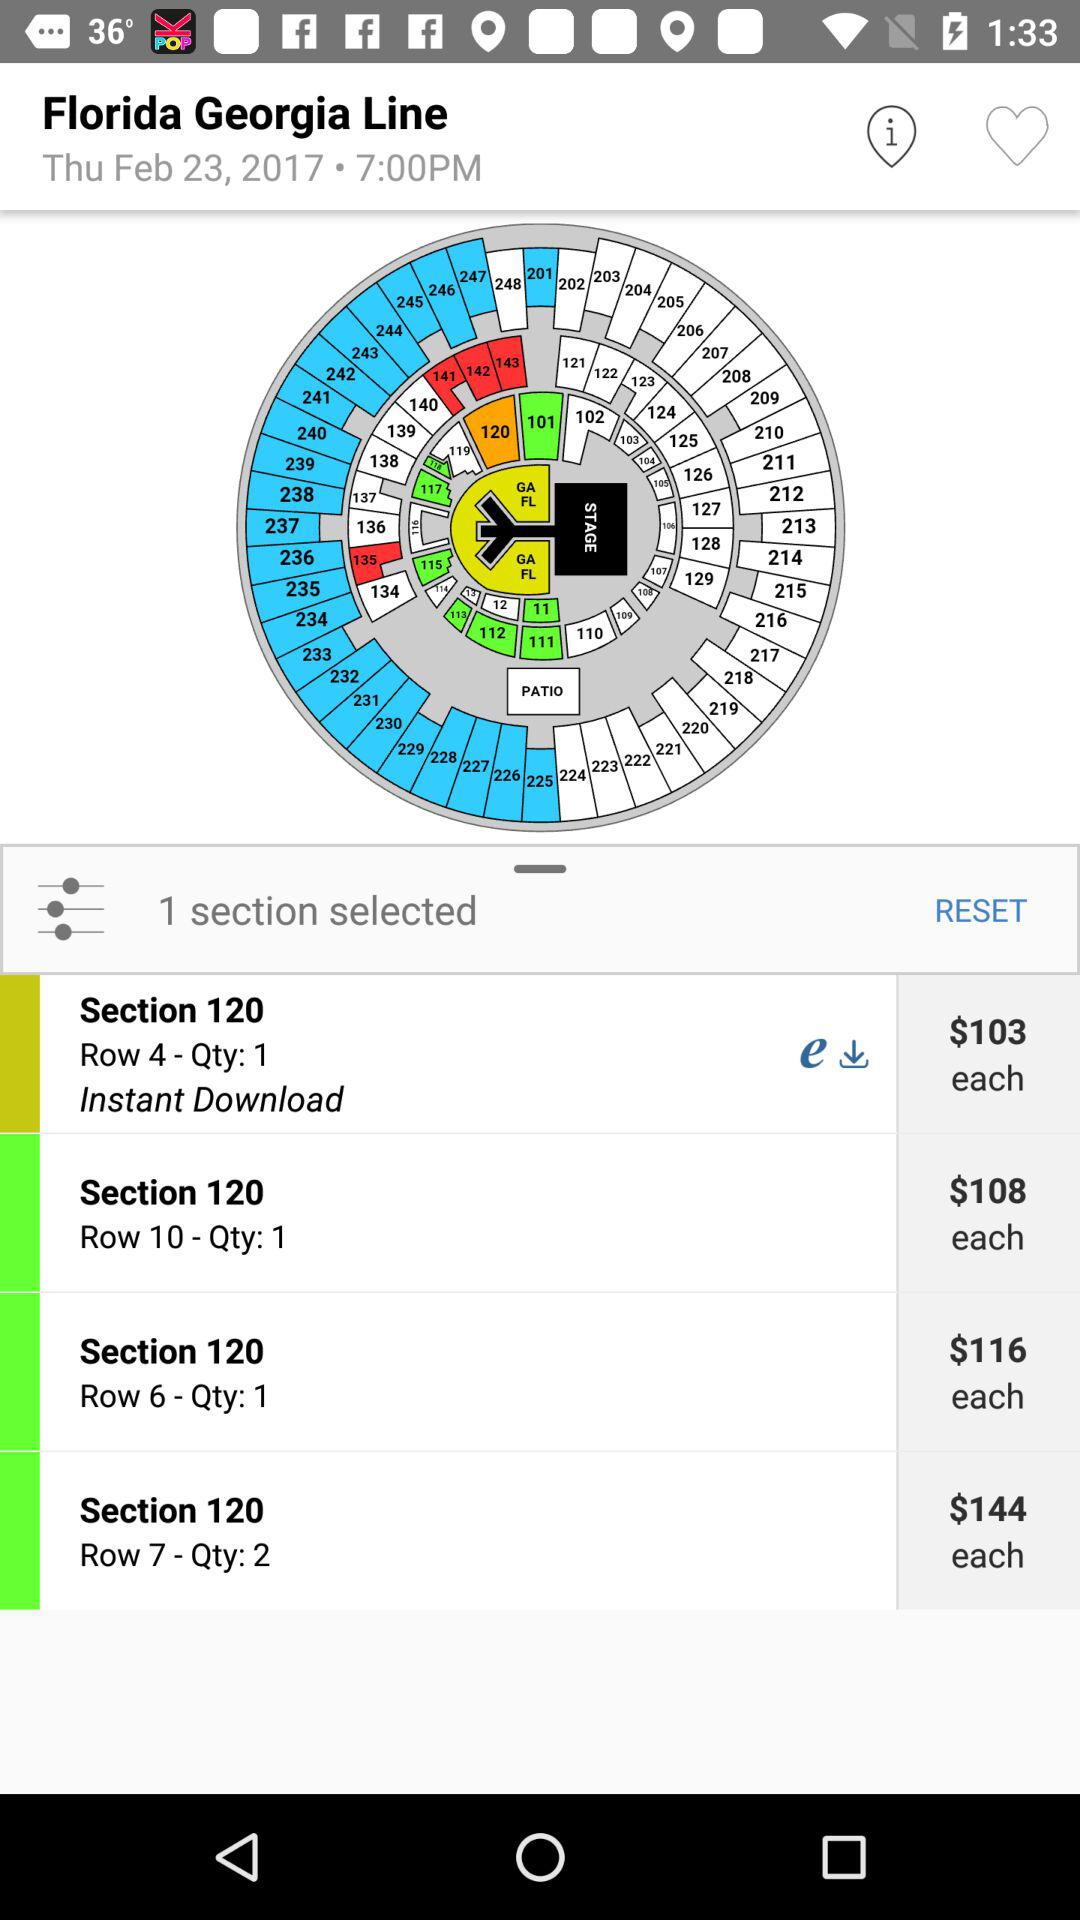What is the cost for section 120, row 4? The cost for section 120, row 4 is $103 each. 